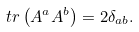<formula> <loc_0><loc_0><loc_500><loc_500>t r \left ( A ^ { a } A ^ { b } \right ) = 2 \delta _ { a b } .</formula> 